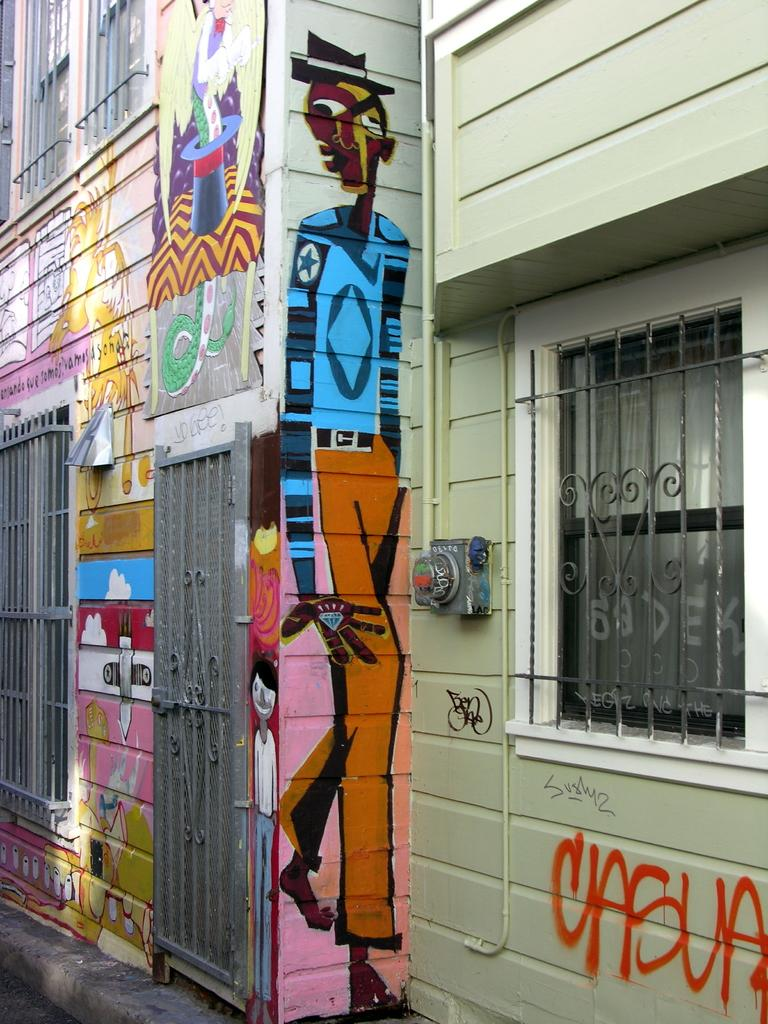Where was the image taken? The image was taken outside a street. What can be seen on the walls in the image? The walls in the image have different images painted on them. Can you describe the right side of the image? There is a window on the right side of the image. What is present on the left side of the image? There is a window and a gate on the left side of the image. What type of bun is being used to hold the gate open in the image? There is no bun present in the image, and the gate is not being held open. What emotion can be seen on the faces of the people in the image? The image does not show any people, so their emotions cannot be determined. 